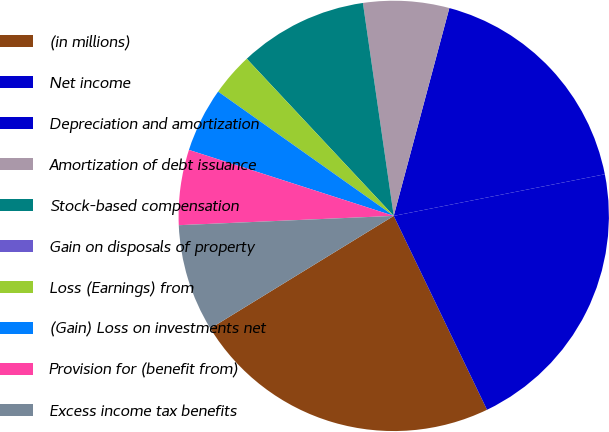Convert chart. <chart><loc_0><loc_0><loc_500><loc_500><pie_chart><fcel>(in millions)<fcel>Net income<fcel>Depreciation and amortization<fcel>Amortization of debt issuance<fcel>Stock-based compensation<fcel>Gain on disposals of property<fcel>Loss (Earnings) from<fcel>(Gain) Loss on investments net<fcel>Provision for (benefit from)<fcel>Excess income tax benefits<nl><fcel>23.38%<fcel>20.96%<fcel>17.74%<fcel>6.45%<fcel>9.68%<fcel>0.0%<fcel>3.23%<fcel>4.84%<fcel>5.65%<fcel>8.07%<nl></chart> 